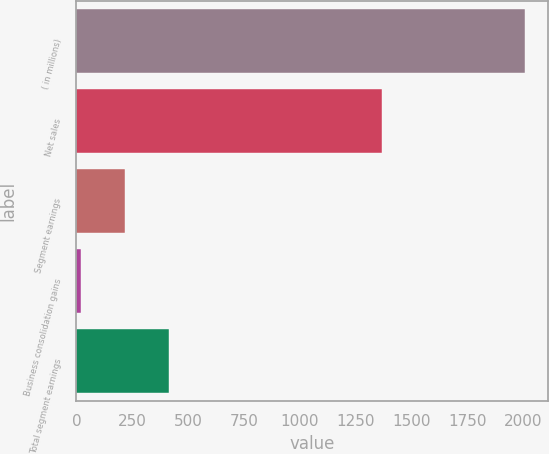<chart> <loc_0><loc_0><loc_500><loc_500><bar_chart><fcel>( in millions)<fcel>Net sales<fcel>Segment earnings<fcel>Business consolidation gains<fcel>Total segment earnings<nl><fcel>2010<fcel>1370.1<fcel>217.47<fcel>18.3<fcel>416.64<nl></chart> 